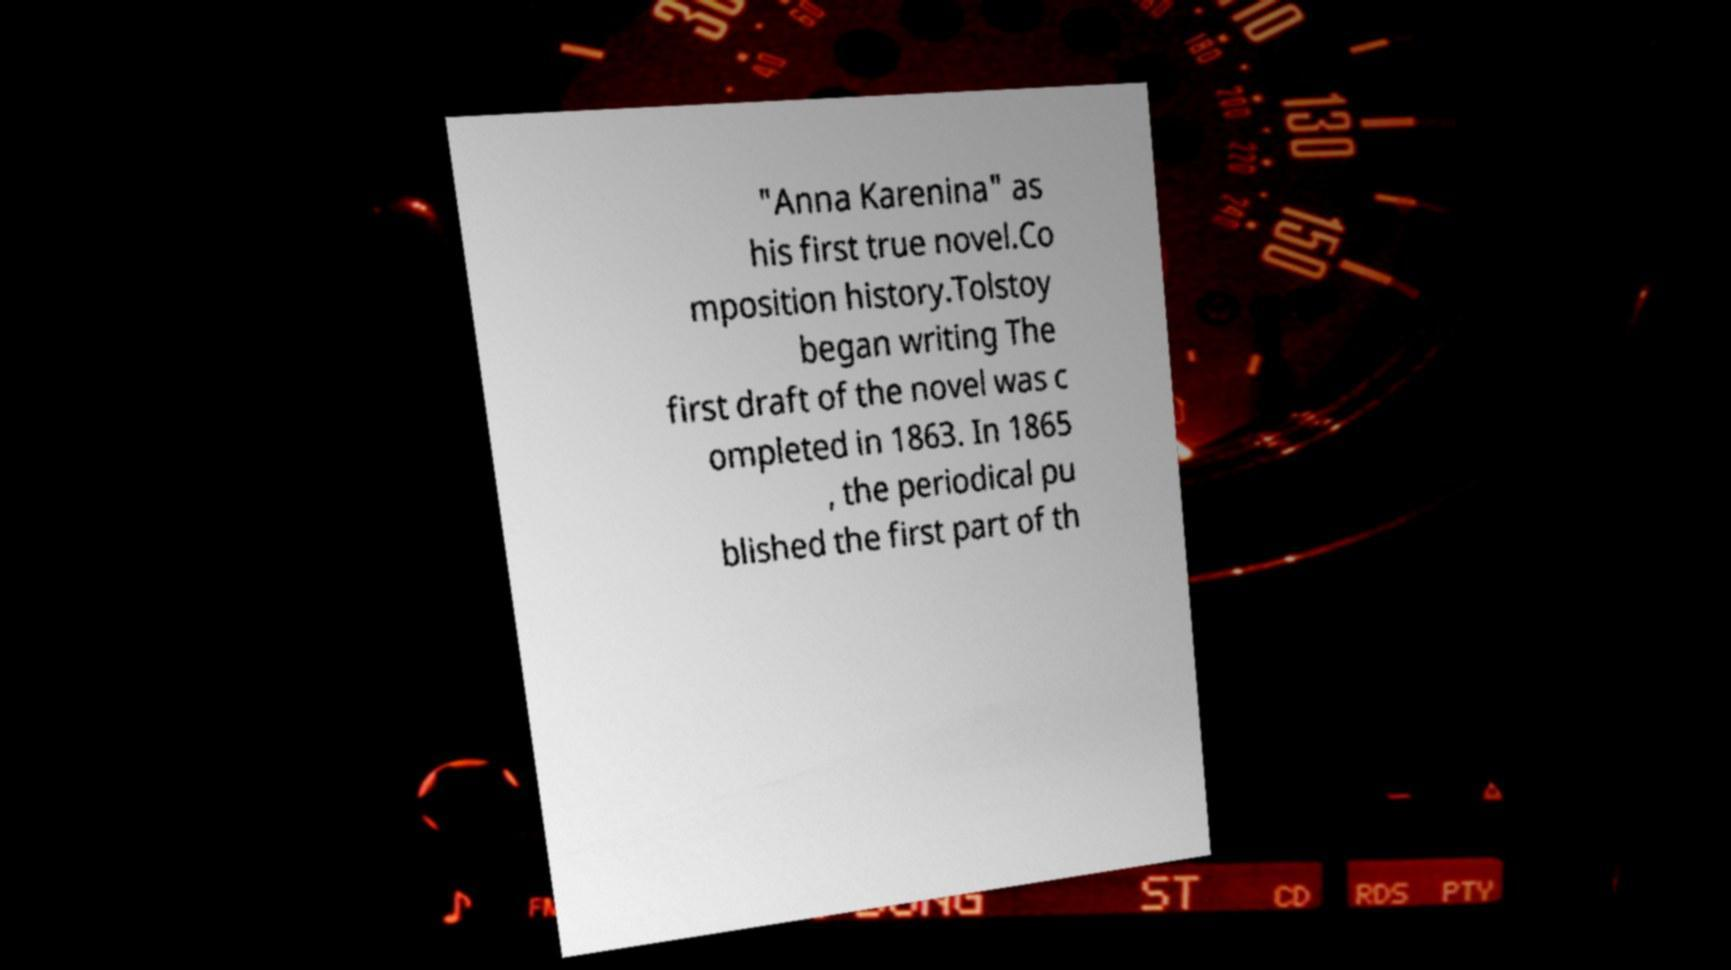Please identify and transcribe the text found in this image. "Anna Karenina" as his first true novel.Co mposition history.Tolstoy began writing The first draft of the novel was c ompleted in 1863. In 1865 , the periodical pu blished the first part of th 